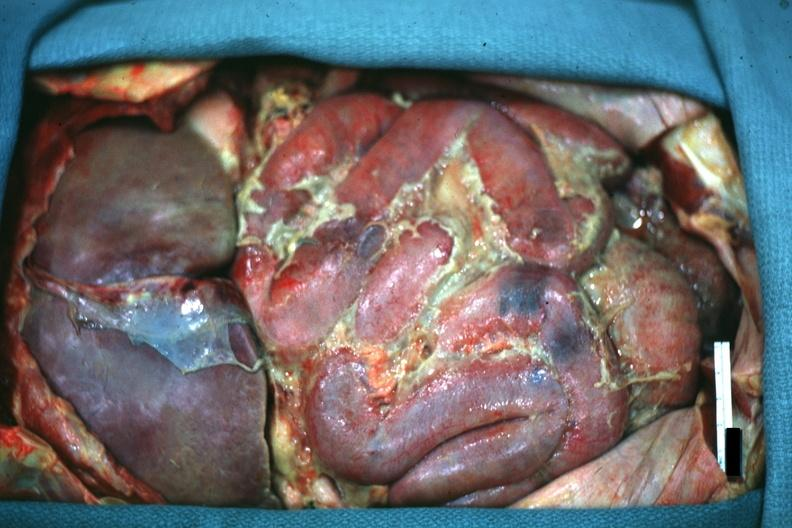s peritoneum present?
Answer the question using a single word or phrase. Yes 